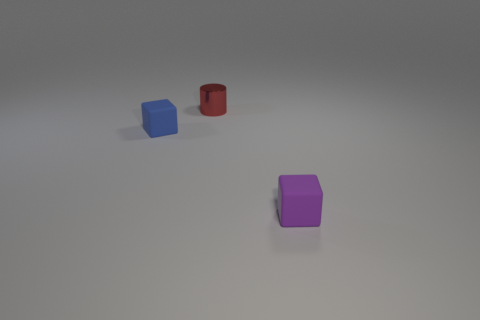How many things are purple cylinders or tiny objects that are behind the tiny blue block?
Your answer should be very brief. 1. Does the small shiny object have the same color as the matte thing that is left of the metal object?
Offer a terse response. No. There is a thing that is both to the right of the small blue block and in front of the tiny red metal cylinder; what size is it?
Offer a very short reply. Small. Are there any red cylinders to the left of the small metallic thing?
Offer a terse response. No. There is a tiny matte cube that is behind the purple thing; are there any blue cubes that are on the right side of it?
Your response must be concise. No. Are there the same number of purple things that are left of the tiny cylinder and small metal things behind the small purple rubber thing?
Give a very brief answer. No. There is a thing that is made of the same material as the purple cube; what is its color?
Make the answer very short. Blue. Is there a big cyan cylinder made of the same material as the small red cylinder?
Offer a terse response. No. How many objects are tiny shiny cylinders or small purple cubes?
Your answer should be compact. 2. Does the blue cube have the same material as the small thing that is behind the tiny blue thing?
Ensure brevity in your answer.  No. 